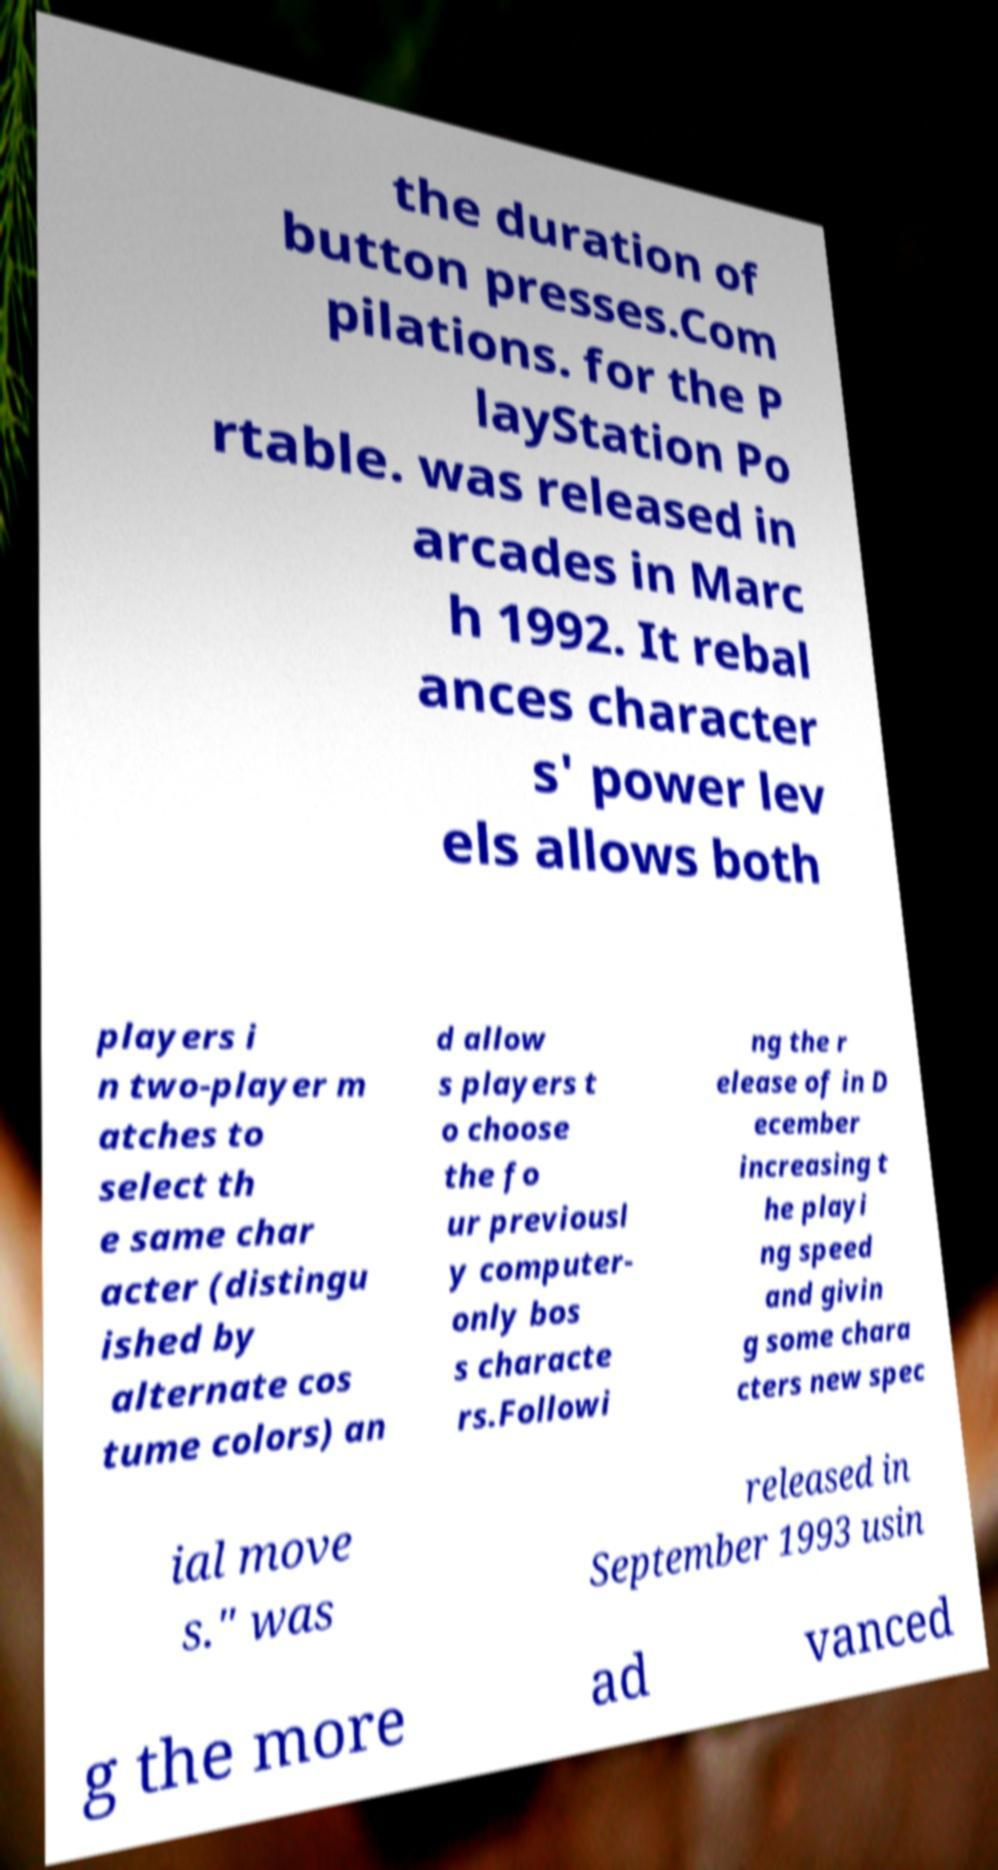Could you assist in decoding the text presented in this image and type it out clearly? the duration of button presses.Com pilations. for the P layStation Po rtable. was released in arcades in Marc h 1992. It rebal ances character s' power lev els allows both players i n two-player m atches to select th e same char acter (distingu ished by alternate cos tume colors) an d allow s players t o choose the fo ur previousl y computer- only bos s characte rs.Followi ng the r elease of in D ecember increasing t he playi ng speed and givin g some chara cters new spec ial move s." was released in September 1993 usin g the more ad vanced 